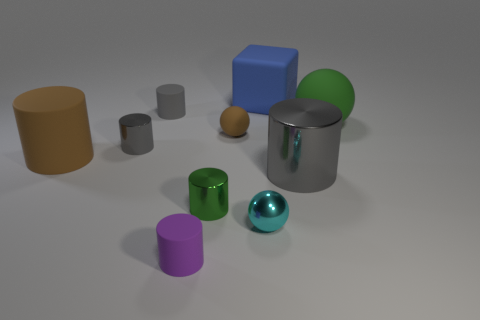How many other things are the same shape as the tiny green object?
Give a very brief answer. 5. There is a gray metallic object on the right side of the purple rubber object; what is its size?
Provide a succinct answer. Large. There is a tiny gray cylinder that is behind the tiny brown rubber ball; what number of big green matte balls are in front of it?
Keep it short and to the point. 1. How many other objects are there of the same size as the rubber block?
Give a very brief answer. 3. Is the big matte cube the same color as the metal sphere?
Provide a succinct answer. No. Do the large rubber thing that is to the right of the blue rubber thing and the tiny brown object have the same shape?
Keep it short and to the point. Yes. How many spheres are to the left of the big blue cube and behind the large brown rubber cylinder?
Provide a short and direct response. 1. What is the tiny purple cylinder made of?
Your answer should be compact. Rubber. Are there any other things that are the same color as the large rubber ball?
Make the answer very short. Yes. Does the brown cylinder have the same material as the blue cube?
Offer a very short reply. Yes. 